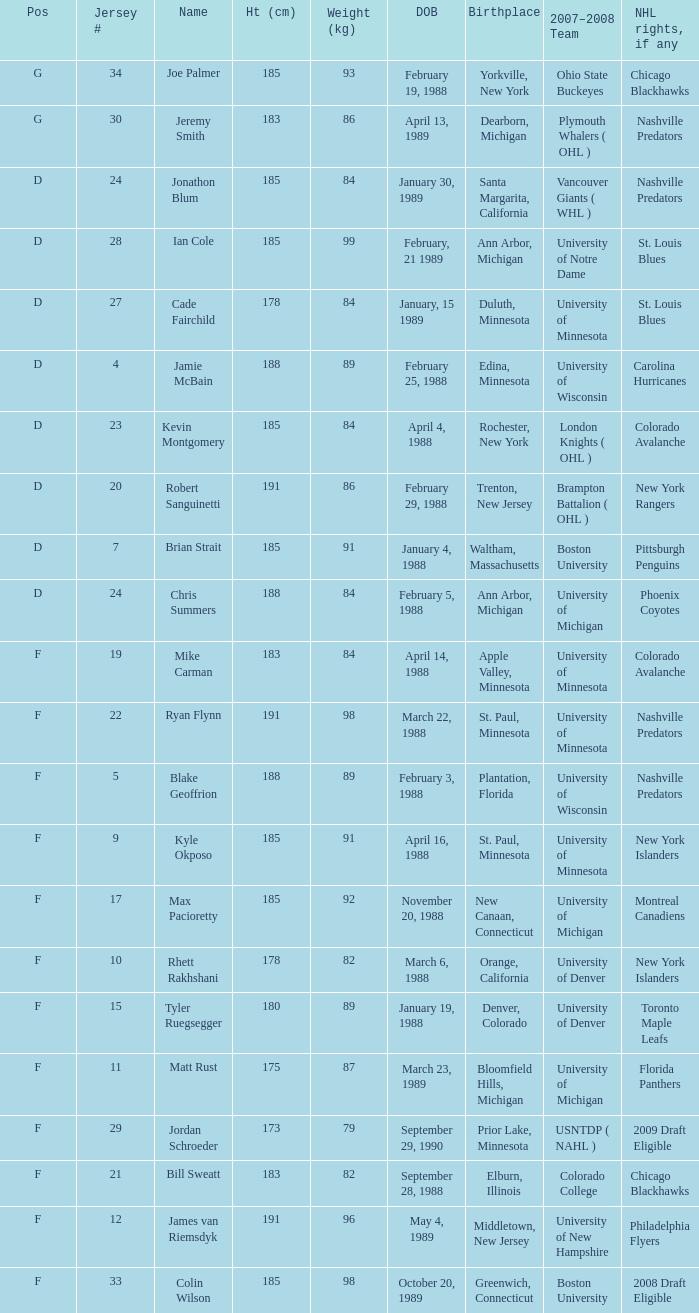Which Weight (kg) has a NHL rights, if any of phoenix coyotes? 1.0. 